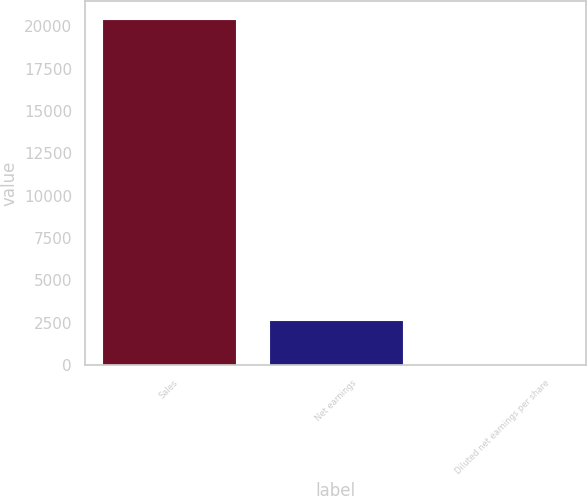Convert chart. <chart><loc_0><loc_0><loc_500><loc_500><bar_chart><fcel>Sales<fcel>Net earnings<fcel>Diluted net earnings per share<nl><fcel>20459.2<fcel>2689.9<fcel>3.79<nl></chart> 